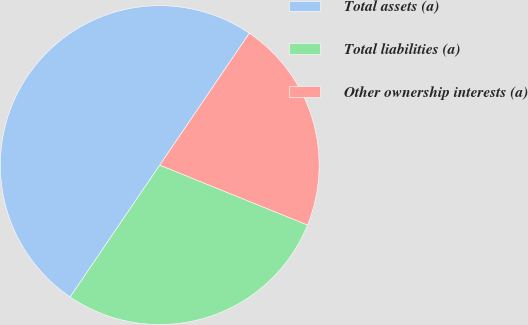<chart> <loc_0><loc_0><loc_500><loc_500><pie_chart><fcel>Total assets (a)<fcel>Total liabilities (a)<fcel>Other ownership interests (a)<nl><fcel>50.0%<fcel>28.37%<fcel>21.63%<nl></chart> 